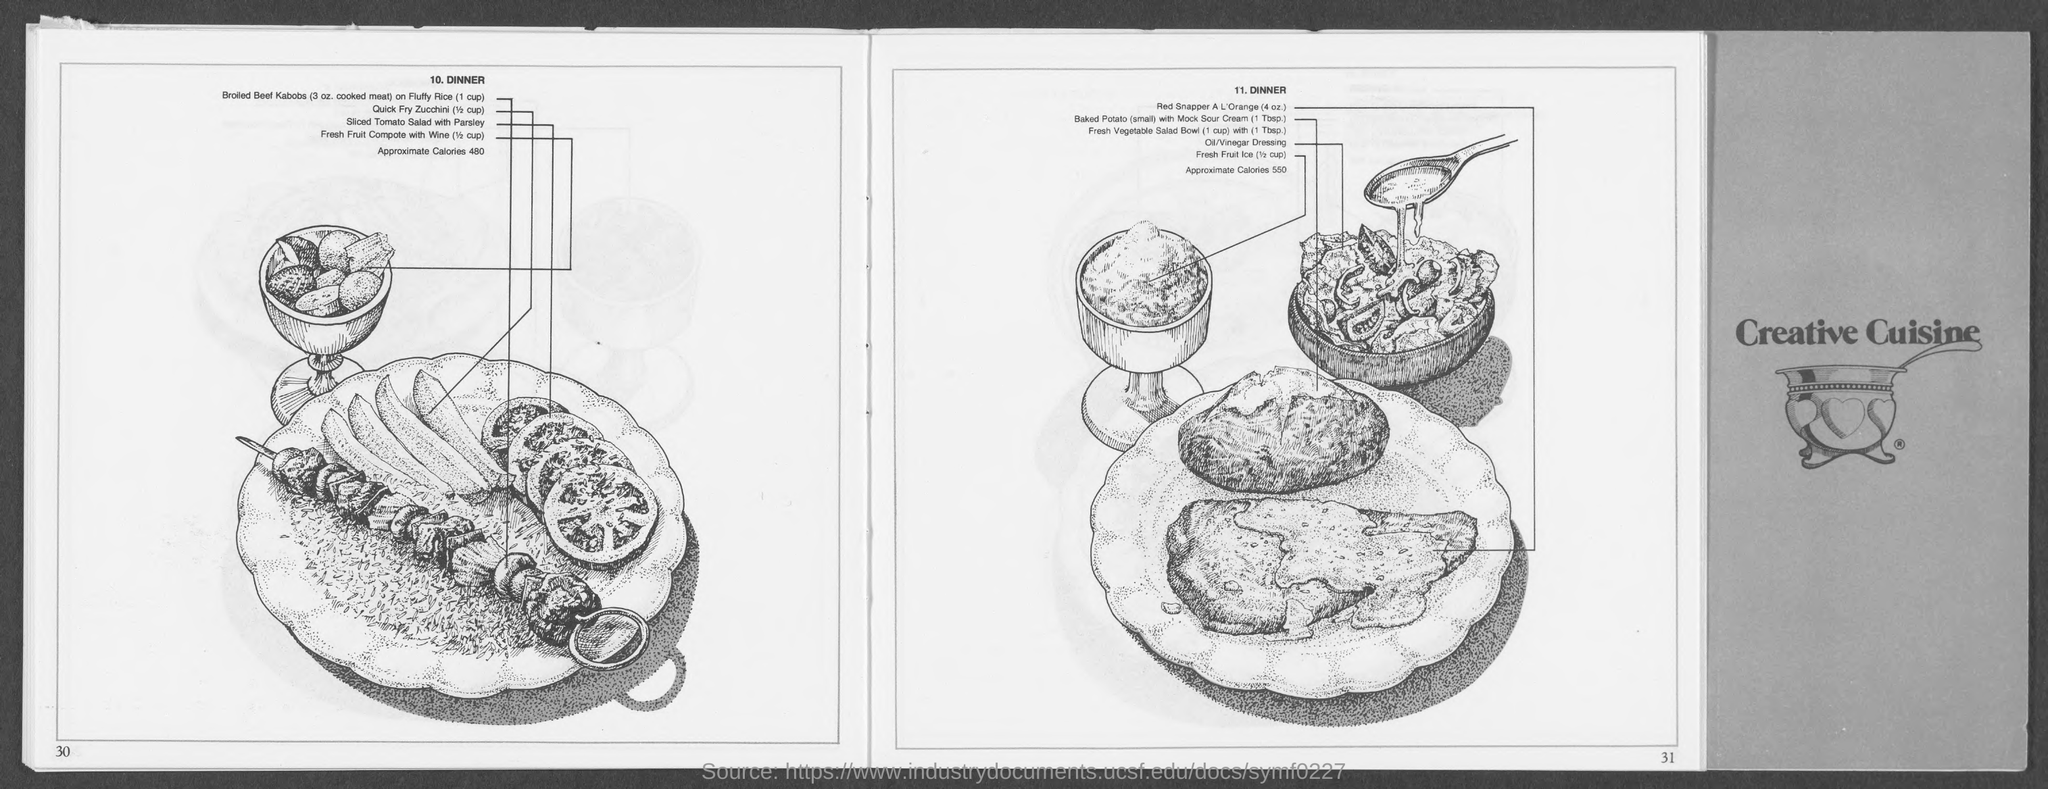Give some essential details in this illustration. The name of number 10 is Dinner. 